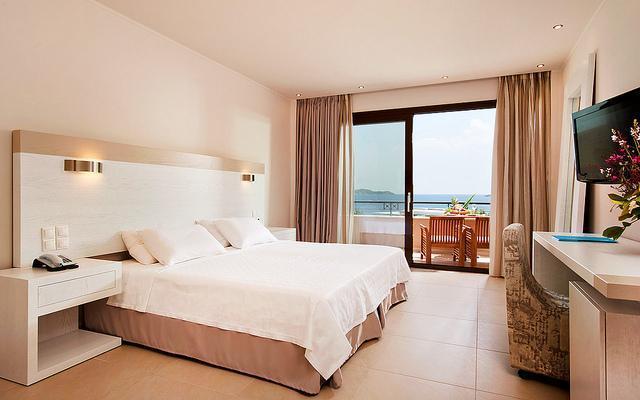How many chairs are in the room?
Give a very brief answer. 1. How many pillows are on the bed?
Give a very brief answer. 4. How many laptops are in the bedroom?
Give a very brief answer. 0. How many rackets is the man holding?
Give a very brief answer. 0. 